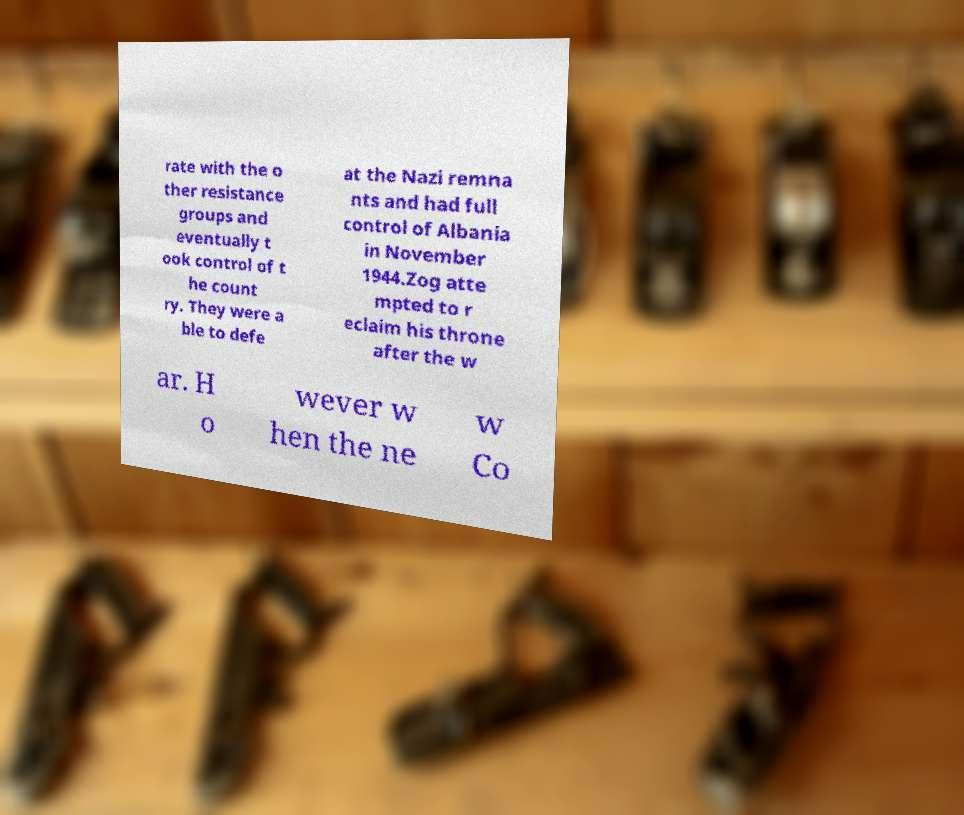Please identify and transcribe the text found in this image. rate with the o ther resistance groups and eventually t ook control of t he count ry. They were a ble to defe at the Nazi remna nts and had full control of Albania in November 1944.Zog atte mpted to r eclaim his throne after the w ar. H o wever w hen the ne w Co 